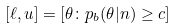Convert formula to latex. <formula><loc_0><loc_0><loc_500><loc_500>[ \ell , u ] = [ \theta \colon p _ { b } ( \theta | n ) \geq c ]</formula> 